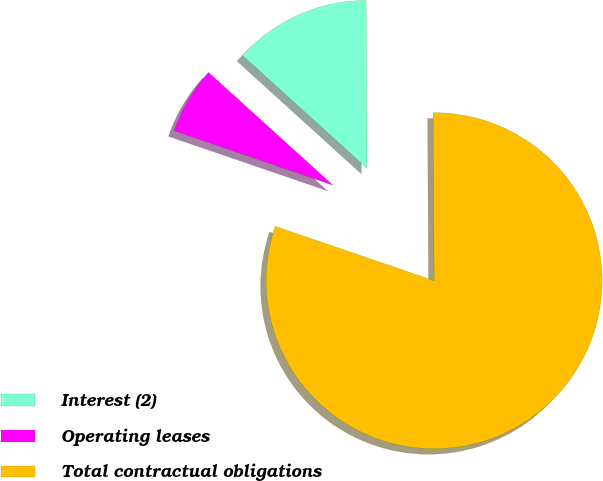Convert chart to OTSL. <chart><loc_0><loc_0><loc_500><loc_500><pie_chart><fcel>Interest (2)<fcel>Operating leases<fcel>Total contractual obligations<nl><fcel>13.19%<fcel>6.47%<fcel>80.34%<nl></chart> 